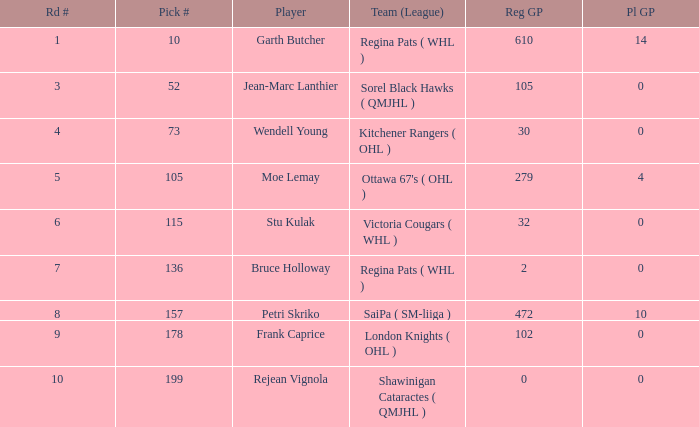What is the aggregate amount of pl gp when the chosen number is 178 and the pathway number exceeds 9? 0.0. 